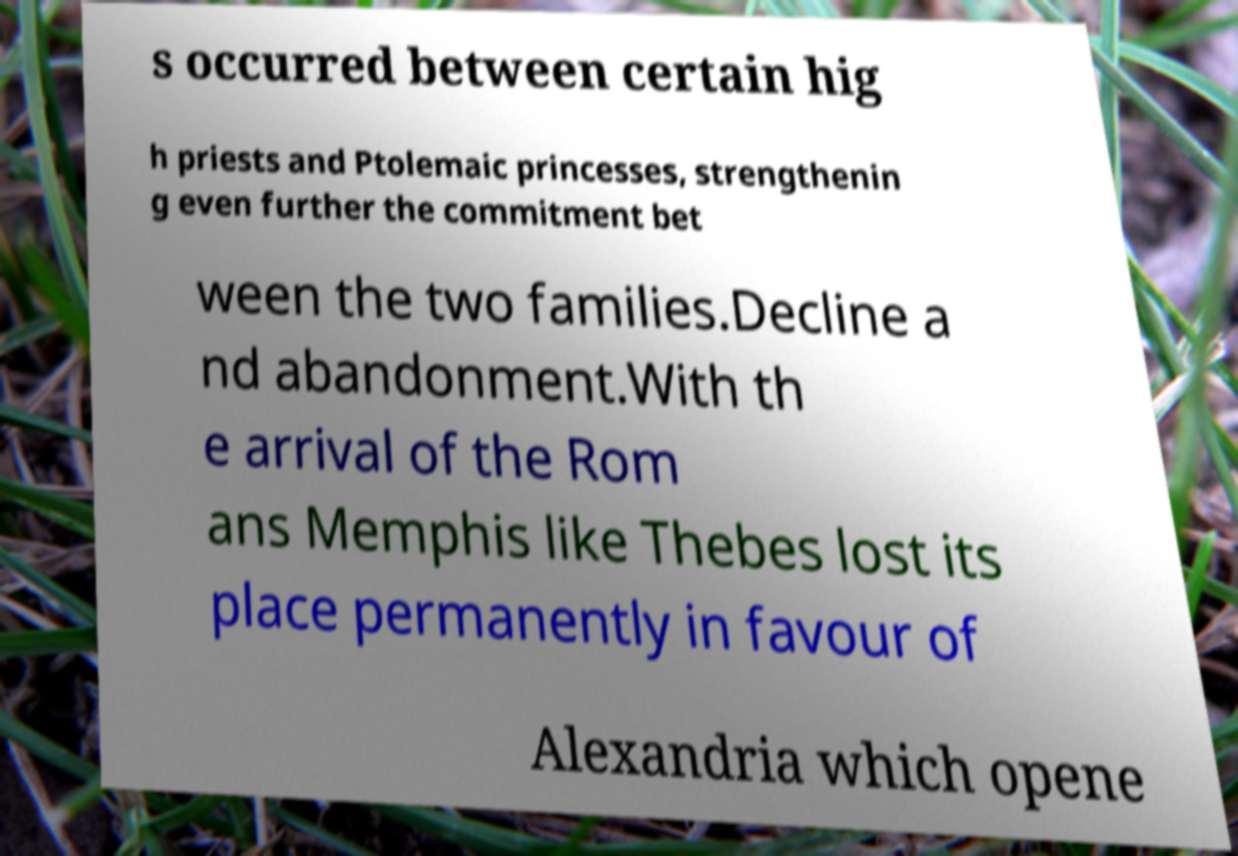I need the written content from this picture converted into text. Can you do that? s occurred between certain hig h priests and Ptolemaic princesses, strengthenin g even further the commitment bet ween the two families.Decline a nd abandonment.With th e arrival of the Rom ans Memphis like Thebes lost its place permanently in favour of Alexandria which opene 